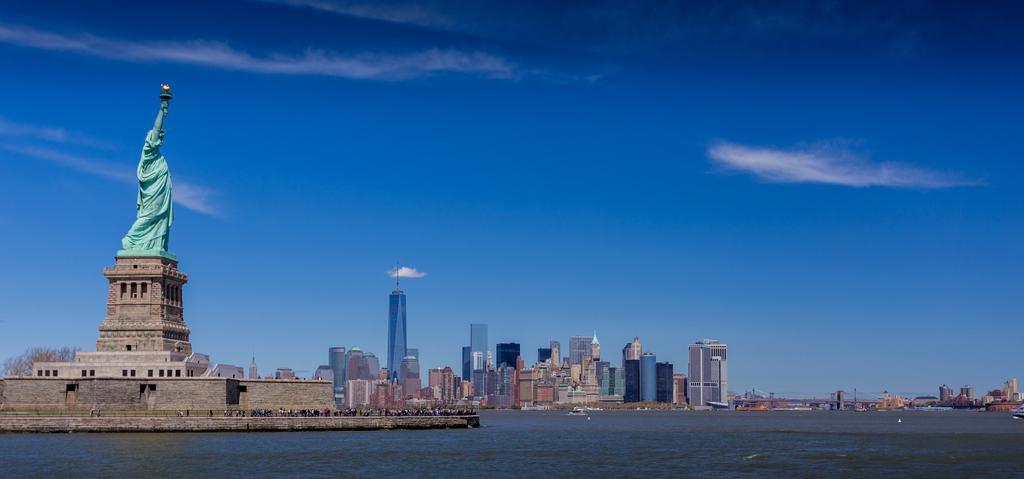Can you describe this image briefly? In the image we can see there is a statue of liberty and there are people standing on the ground. There is water and behind there are lot of buildings. There is clear sky on the top. 